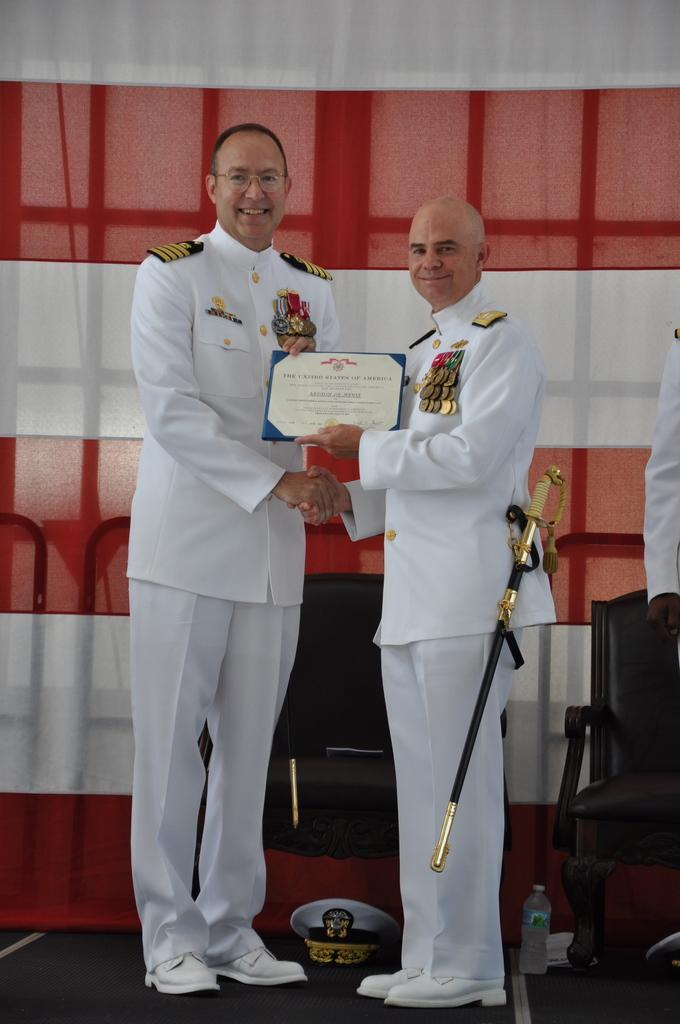How many people are in the image? There are two persons standing in the center of the image. What is the facial expression of the persons in the image? The persons are smiling. What object is visible at the bottom of the image? A cap is visible at the bottom of the image. What can be seen in the background of the image? There is a curtain in the background of the image. What type of flag is visible in the image? There is no flag present in the image. How does the stomach of the person on the left feel in the image? There is no information about the person's stomach in the image, so it cannot be determined. 